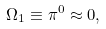Convert formula to latex. <formula><loc_0><loc_0><loc_500><loc_500>\Omega _ { 1 } \equiv \pi ^ { 0 } \approx 0 ,</formula> 